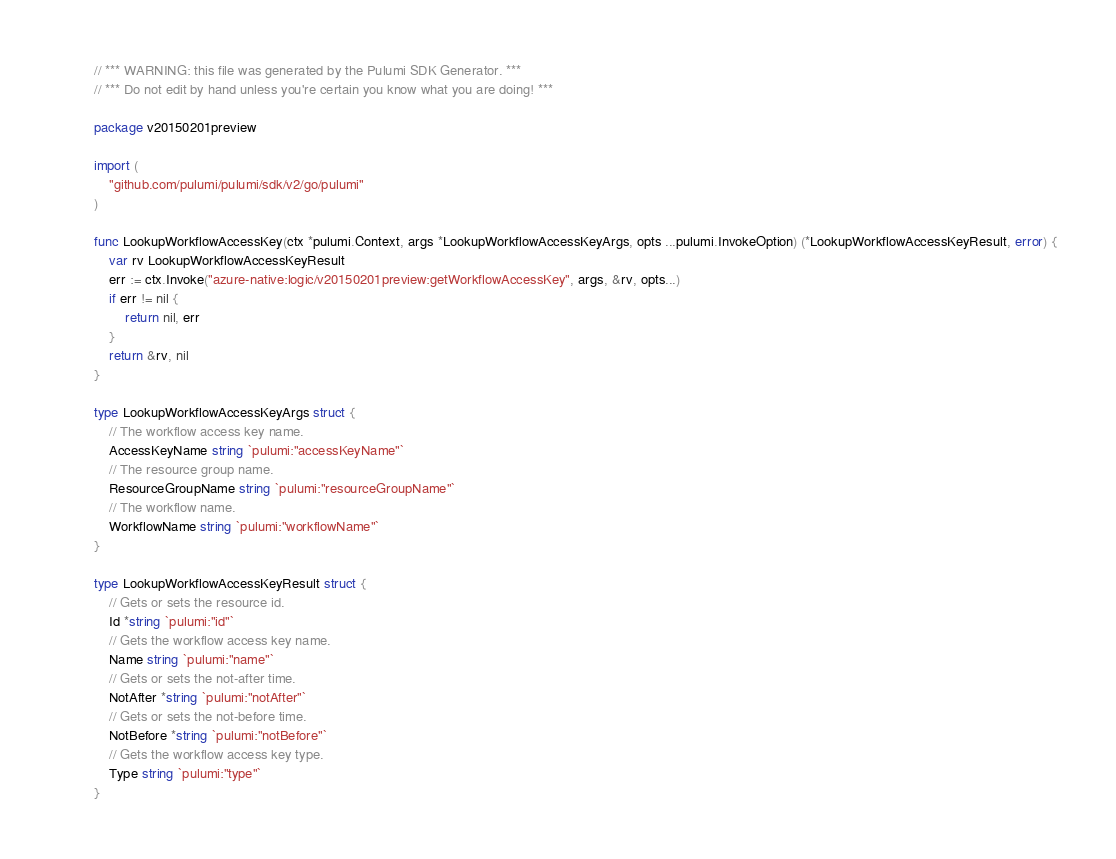<code> <loc_0><loc_0><loc_500><loc_500><_Go_>// *** WARNING: this file was generated by the Pulumi SDK Generator. ***
// *** Do not edit by hand unless you're certain you know what you are doing! ***

package v20150201preview

import (
	"github.com/pulumi/pulumi/sdk/v2/go/pulumi"
)

func LookupWorkflowAccessKey(ctx *pulumi.Context, args *LookupWorkflowAccessKeyArgs, opts ...pulumi.InvokeOption) (*LookupWorkflowAccessKeyResult, error) {
	var rv LookupWorkflowAccessKeyResult
	err := ctx.Invoke("azure-native:logic/v20150201preview:getWorkflowAccessKey", args, &rv, opts...)
	if err != nil {
		return nil, err
	}
	return &rv, nil
}

type LookupWorkflowAccessKeyArgs struct {
	// The workflow access key name.
	AccessKeyName string `pulumi:"accessKeyName"`
	// The resource group name.
	ResourceGroupName string `pulumi:"resourceGroupName"`
	// The workflow name.
	WorkflowName string `pulumi:"workflowName"`
}

type LookupWorkflowAccessKeyResult struct {
	// Gets or sets the resource id.
	Id *string `pulumi:"id"`
	// Gets the workflow access key name.
	Name string `pulumi:"name"`
	// Gets or sets the not-after time.
	NotAfter *string `pulumi:"notAfter"`
	// Gets or sets the not-before time.
	NotBefore *string `pulumi:"notBefore"`
	// Gets the workflow access key type.
	Type string `pulumi:"type"`
}
</code> 